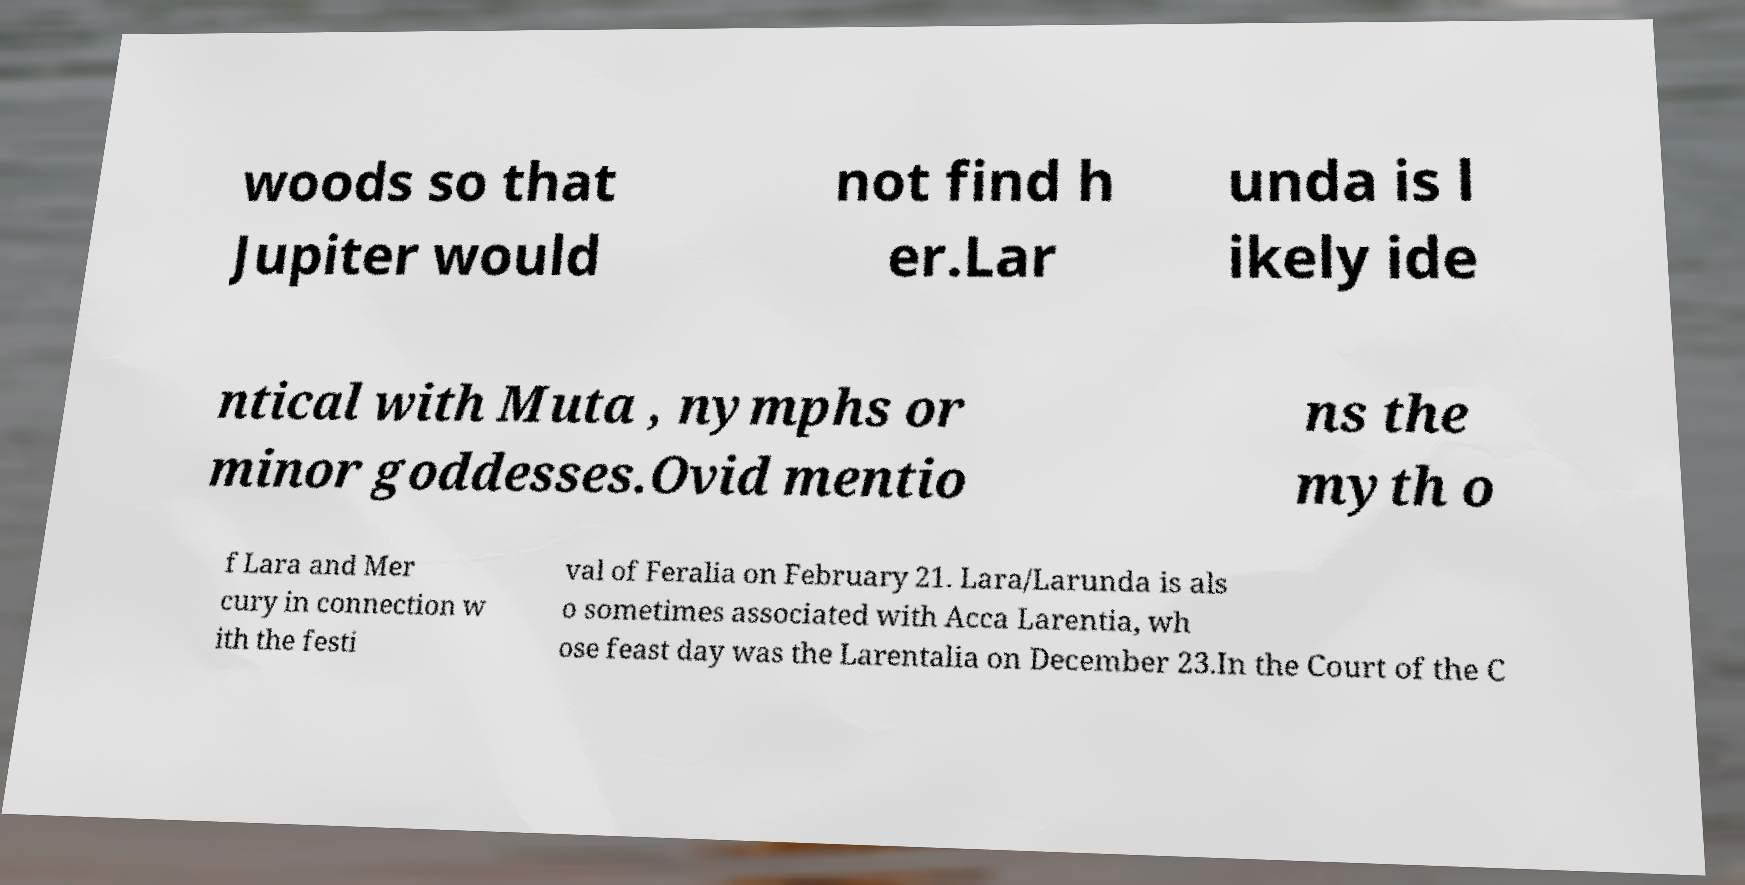Can you accurately transcribe the text from the provided image for me? woods so that Jupiter would not find h er.Lar unda is l ikely ide ntical with Muta , nymphs or minor goddesses.Ovid mentio ns the myth o f Lara and Mer cury in connection w ith the festi val of Feralia on February 21. Lara/Larunda is als o sometimes associated with Acca Larentia, wh ose feast day was the Larentalia on December 23.In the Court of the C 